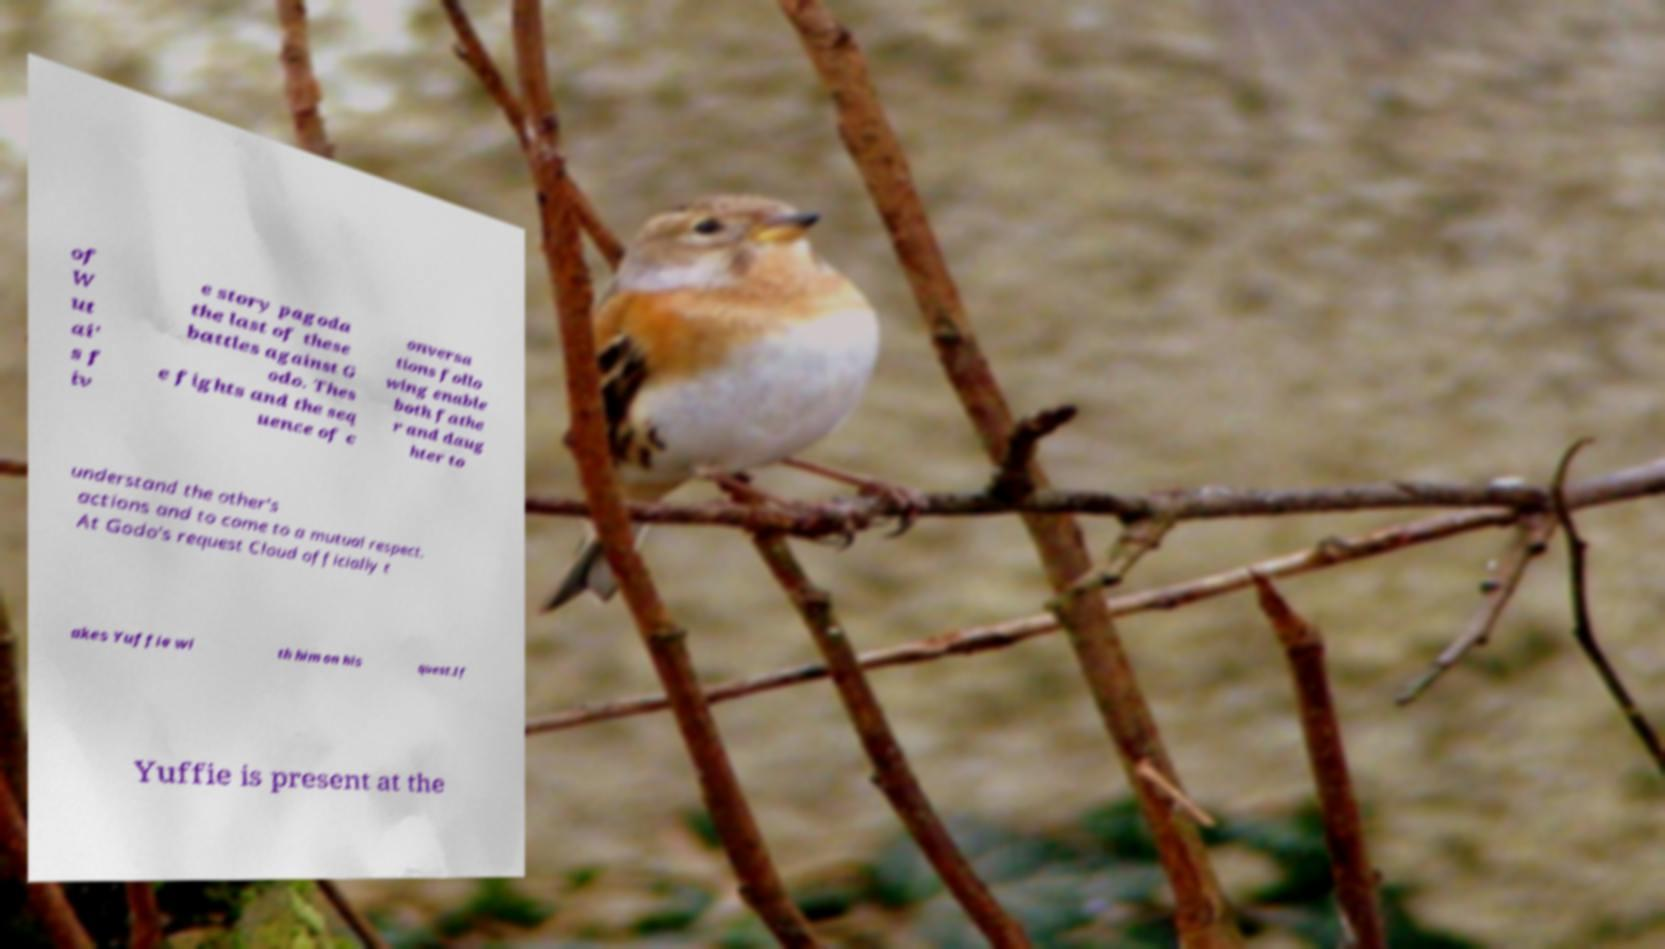Can you read and provide the text displayed in the image?This photo seems to have some interesting text. Can you extract and type it out for me? of W ut ai' s f iv e story pagoda the last of these battles against G odo. Thes e fights and the seq uence of c onversa tions follo wing enable both fathe r and daug hter to understand the other's actions and to come to a mutual respect. At Godo's request Cloud officially t akes Yuffie wi th him on his quest.If Yuffie is present at the 